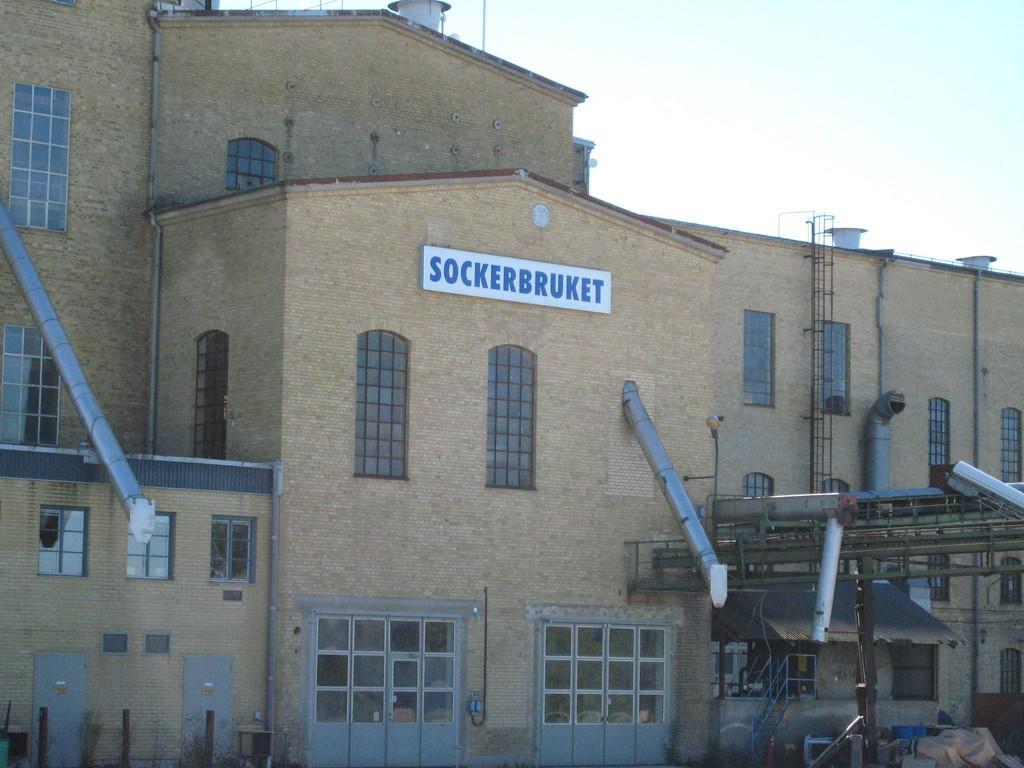How would you summarize this image in a sentence or two? In this picture we can see a building with pipes and other things. Behind the building there is a sky. 